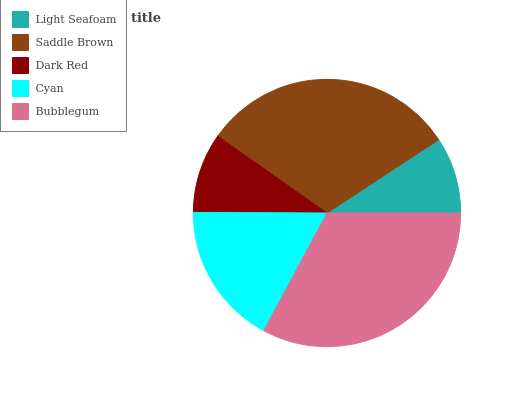Is Light Seafoam the minimum?
Answer yes or no. Yes. Is Bubblegum the maximum?
Answer yes or no. Yes. Is Saddle Brown the minimum?
Answer yes or no. No. Is Saddle Brown the maximum?
Answer yes or no. No. Is Saddle Brown greater than Light Seafoam?
Answer yes or no. Yes. Is Light Seafoam less than Saddle Brown?
Answer yes or no. Yes. Is Light Seafoam greater than Saddle Brown?
Answer yes or no. No. Is Saddle Brown less than Light Seafoam?
Answer yes or no. No. Is Cyan the high median?
Answer yes or no. Yes. Is Cyan the low median?
Answer yes or no. Yes. Is Light Seafoam the high median?
Answer yes or no. No. Is Bubblegum the low median?
Answer yes or no. No. 